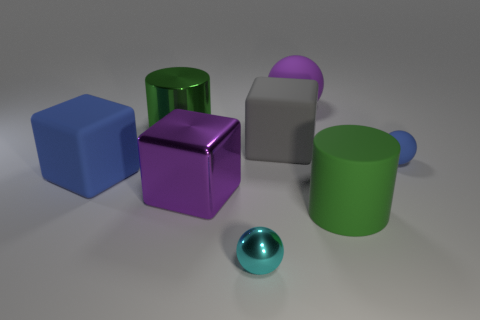Are there any other things that are the same size as the cyan shiny ball?
Ensure brevity in your answer.  Yes. How many objects are big metal cylinders that are right of the big blue rubber block or large green cylinders that are behind the purple block?
Provide a succinct answer. 1. Does the blue object that is behind the big blue rubber block have the same size as the green thing that is to the left of the large gray matte block?
Provide a short and direct response. No. There is a big metal thing that is the same shape as the big gray rubber thing; what color is it?
Keep it short and to the point. Purple. Is there anything else that is the same shape as the big blue thing?
Your answer should be very brief. Yes. Are there more cyan metal spheres on the left side of the cyan metallic object than blue spheres that are to the right of the big purple sphere?
Keep it short and to the point. No. There is a block in front of the blue matte object to the left of the purple object that is in front of the big green metallic cylinder; how big is it?
Provide a short and direct response. Large. Is the large blue thing made of the same material as the purple object that is behind the large metallic cube?
Make the answer very short. Yes. Is the big green matte thing the same shape as the small metal thing?
Keep it short and to the point. No. How many other things are made of the same material as the purple block?
Your answer should be compact. 2. 